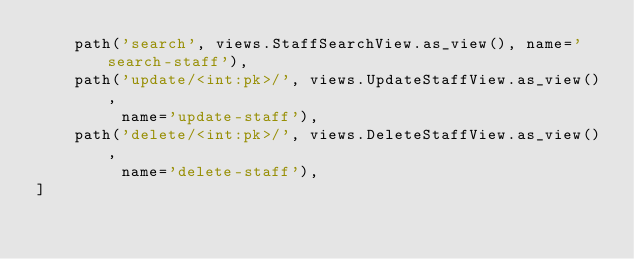Convert code to text. <code><loc_0><loc_0><loc_500><loc_500><_Python_>    path('search', views.StaffSearchView.as_view(), name='search-staff'),
    path('update/<int:pk>/', views.UpdateStaffView.as_view(),
         name='update-staff'),
    path('delete/<int:pk>/', views.DeleteStaffView.as_view(),
         name='delete-staff'),
]
</code> 